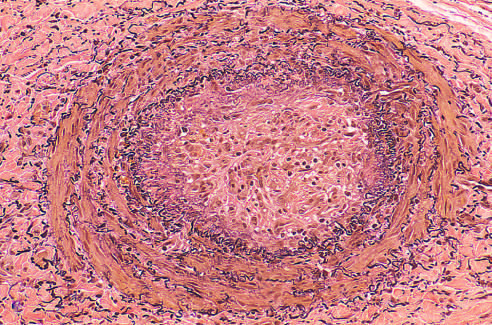s a thrombosed artery stained for elastic tissue?
Answer the question using a single word or phrase. Yes 